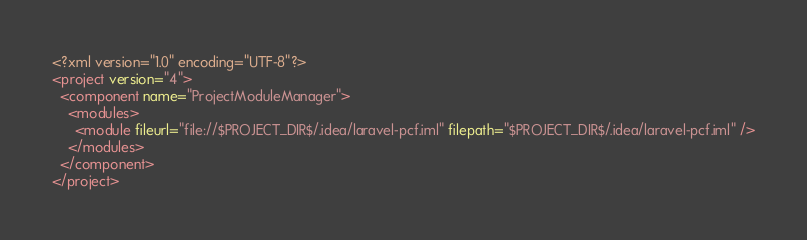<code> <loc_0><loc_0><loc_500><loc_500><_XML_><?xml version="1.0" encoding="UTF-8"?>
<project version="4">
  <component name="ProjectModuleManager">
    <modules>
      <module fileurl="file://$PROJECT_DIR$/.idea/laravel-pcf.iml" filepath="$PROJECT_DIR$/.idea/laravel-pcf.iml" />
    </modules>
  </component>
</project></code> 